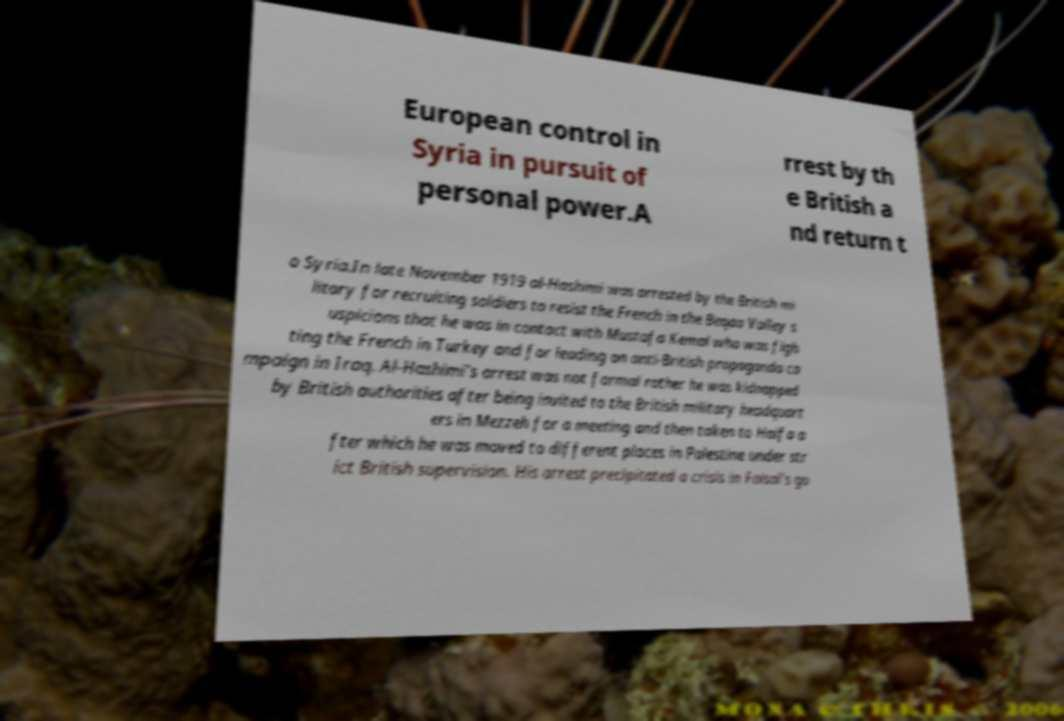Can you accurately transcribe the text from the provided image for me? European control in Syria in pursuit of personal power.A rrest by th e British a nd return t o Syria.In late November 1919 al-Hashimi was arrested by the British mi litary for recruiting soldiers to resist the French in the Beqaa Valley s uspicions that he was in contact with Mustafa Kemal who was figh ting the French in Turkey and for leading an anti-British propaganda ca mpaign in Iraq. Al-Hashimi's arrest was not formal rather he was kidnapped by British authorities after being invited to the British military headquart ers in Mezzeh for a meeting and then taken to Haifa a fter which he was moved to different places in Palestine under str ict British supervision. His arrest precipitated a crisis in Faisal's go 